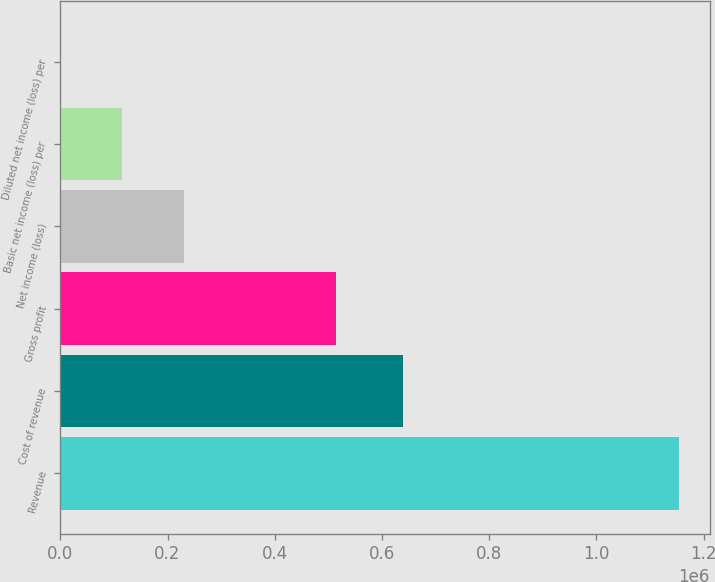Convert chart to OTSL. <chart><loc_0><loc_0><loc_500><loc_500><bar_chart><fcel>Revenue<fcel>Cost of revenue<fcel>Gross profit<fcel>Net income (loss)<fcel>Basic net income (loss) per<fcel>Diluted net income (loss) per<nl><fcel>1.15339e+06<fcel>638545<fcel>514843<fcel>230678<fcel>115339<fcel>0.3<nl></chart> 